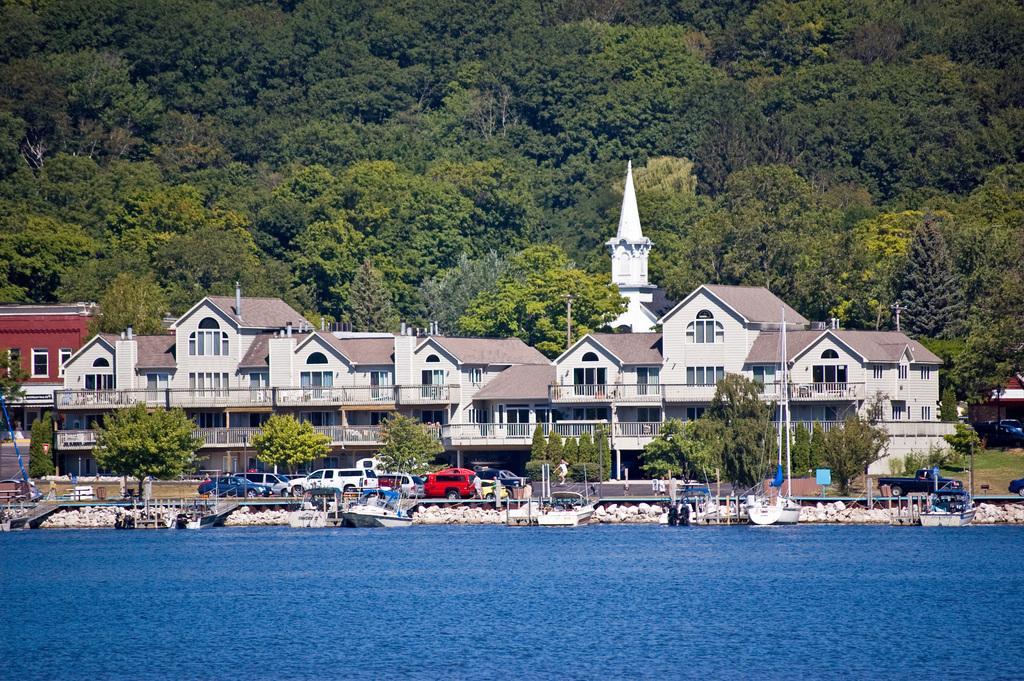Can you describe this image briefly? In this image we can see buildings, grills, poles, motor vehicles, ships at the deck, rocks, water and trees. 